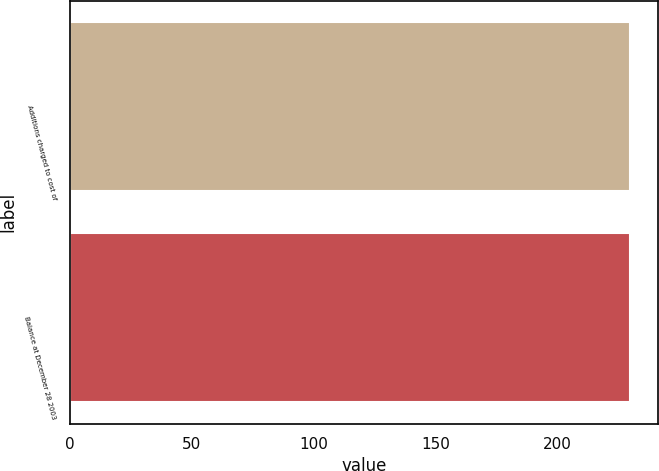Convert chart to OTSL. <chart><loc_0><loc_0><loc_500><loc_500><bar_chart><fcel>Additions charged to cost of<fcel>Balance at December 28 2003<nl><fcel>230<fcel>230.1<nl></chart> 